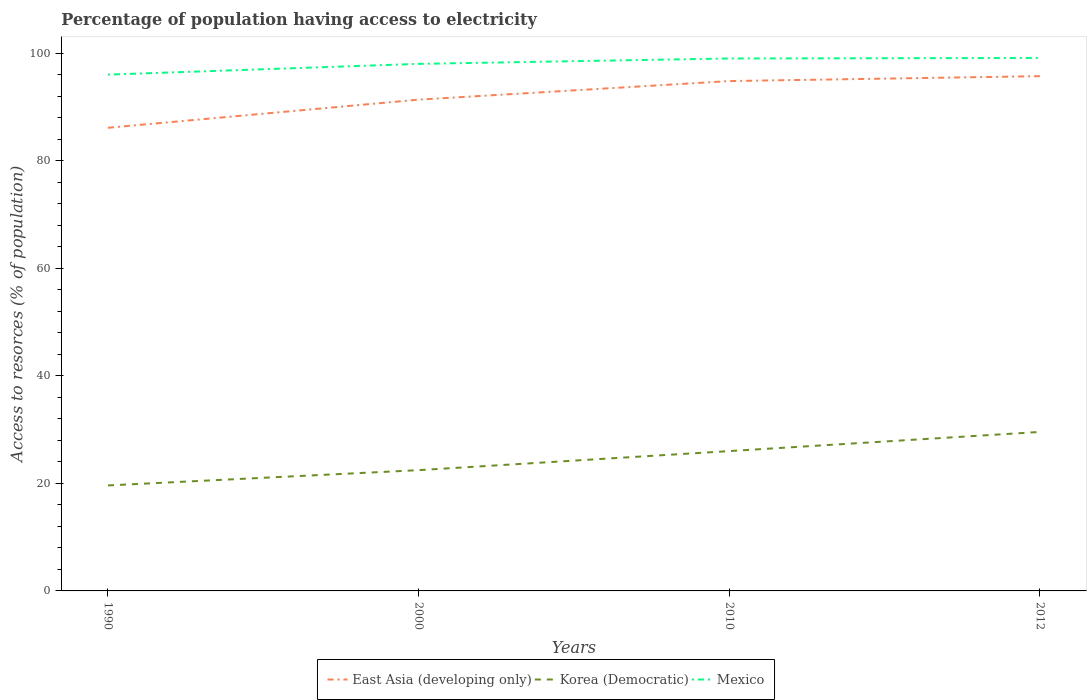How many different coloured lines are there?
Your response must be concise. 3. Across all years, what is the maximum percentage of population having access to electricity in Mexico?
Your response must be concise. 96. What is the total percentage of population having access to electricity in Mexico in the graph?
Ensure brevity in your answer.  -1.1. What is the difference between the highest and the second highest percentage of population having access to electricity in East Asia (developing only)?
Offer a terse response. 9.59. What is the difference between two consecutive major ticks on the Y-axis?
Give a very brief answer. 20. Does the graph contain any zero values?
Ensure brevity in your answer.  No. Does the graph contain grids?
Offer a terse response. No. Where does the legend appear in the graph?
Give a very brief answer. Bottom center. How are the legend labels stacked?
Make the answer very short. Horizontal. What is the title of the graph?
Your answer should be very brief. Percentage of population having access to electricity. Does "Thailand" appear as one of the legend labels in the graph?
Your answer should be compact. No. What is the label or title of the X-axis?
Provide a succinct answer. Years. What is the label or title of the Y-axis?
Offer a terse response. Access to resorces (% of population). What is the Access to resorces (% of population) in East Asia (developing only) in 1990?
Ensure brevity in your answer.  86.12. What is the Access to resorces (% of population) in Korea (Democratic) in 1990?
Your response must be concise. 19.62. What is the Access to resorces (% of population) of Mexico in 1990?
Your response must be concise. 96. What is the Access to resorces (% of population) in East Asia (developing only) in 2000?
Keep it short and to the point. 91.35. What is the Access to resorces (% of population) of Korea (Democratic) in 2000?
Offer a terse response. 22.46. What is the Access to resorces (% of population) of East Asia (developing only) in 2010?
Your response must be concise. 94.8. What is the Access to resorces (% of population) in Korea (Democratic) in 2010?
Your answer should be compact. 26. What is the Access to resorces (% of population) in Mexico in 2010?
Offer a very short reply. 99. What is the Access to resorces (% of population) in East Asia (developing only) in 2012?
Your response must be concise. 95.71. What is the Access to resorces (% of population) of Korea (Democratic) in 2012?
Provide a short and direct response. 29.56. What is the Access to resorces (% of population) of Mexico in 2012?
Your response must be concise. 99.1. Across all years, what is the maximum Access to resorces (% of population) in East Asia (developing only)?
Provide a succinct answer. 95.71. Across all years, what is the maximum Access to resorces (% of population) of Korea (Democratic)?
Your response must be concise. 29.56. Across all years, what is the maximum Access to resorces (% of population) in Mexico?
Offer a very short reply. 99.1. Across all years, what is the minimum Access to resorces (% of population) in East Asia (developing only)?
Ensure brevity in your answer.  86.12. Across all years, what is the minimum Access to resorces (% of population) in Korea (Democratic)?
Make the answer very short. 19.62. Across all years, what is the minimum Access to resorces (% of population) in Mexico?
Your answer should be compact. 96. What is the total Access to resorces (% of population) in East Asia (developing only) in the graph?
Provide a succinct answer. 367.98. What is the total Access to resorces (% of population) in Korea (Democratic) in the graph?
Offer a very short reply. 97.63. What is the total Access to resorces (% of population) in Mexico in the graph?
Make the answer very short. 392.1. What is the difference between the Access to resorces (% of population) of East Asia (developing only) in 1990 and that in 2000?
Provide a short and direct response. -5.23. What is the difference between the Access to resorces (% of population) of Korea (Democratic) in 1990 and that in 2000?
Keep it short and to the point. -2.84. What is the difference between the Access to resorces (% of population) in Mexico in 1990 and that in 2000?
Offer a terse response. -2. What is the difference between the Access to resorces (% of population) in East Asia (developing only) in 1990 and that in 2010?
Provide a short and direct response. -8.68. What is the difference between the Access to resorces (% of population) in Korea (Democratic) in 1990 and that in 2010?
Provide a succinct answer. -6.38. What is the difference between the Access to resorces (% of population) of Mexico in 1990 and that in 2010?
Provide a succinct answer. -3. What is the difference between the Access to resorces (% of population) in East Asia (developing only) in 1990 and that in 2012?
Offer a terse response. -9.59. What is the difference between the Access to resorces (% of population) of Korea (Democratic) in 1990 and that in 2012?
Your response must be concise. -9.95. What is the difference between the Access to resorces (% of population) of East Asia (developing only) in 2000 and that in 2010?
Offer a terse response. -3.45. What is the difference between the Access to resorces (% of population) in Korea (Democratic) in 2000 and that in 2010?
Your answer should be compact. -3.54. What is the difference between the Access to resorces (% of population) of Mexico in 2000 and that in 2010?
Provide a succinct answer. -1. What is the difference between the Access to resorces (% of population) of East Asia (developing only) in 2000 and that in 2012?
Make the answer very short. -4.36. What is the difference between the Access to resorces (% of population) of Korea (Democratic) in 2000 and that in 2012?
Offer a terse response. -7.11. What is the difference between the Access to resorces (% of population) in Mexico in 2000 and that in 2012?
Offer a terse response. -1.1. What is the difference between the Access to resorces (% of population) in East Asia (developing only) in 2010 and that in 2012?
Your answer should be very brief. -0.91. What is the difference between the Access to resorces (% of population) of Korea (Democratic) in 2010 and that in 2012?
Your response must be concise. -3.56. What is the difference between the Access to resorces (% of population) in Mexico in 2010 and that in 2012?
Your answer should be very brief. -0.1. What is the difference between the Access to resorces (% of population) in East Asia (developing only) in 1990 and the Access to resorces (% of population) in Korea (Democratic) in 2000?
Provide a succinct answer. 63.66. What is the difference between the Access to resorces (% of population) of East Asia (developing only) in 1990 and the Access to resorces (% of population) of Mexico in 2000?
Give a very brief answer. -11.88. What is the difference between the Access to resorces (% of population) in Korea (Democratic) in 1990 and the Access to resorces (% of population) in Mexico in 2000?
Provide a succinct answer. -78.38. What is the difference between the Access to resorces (% of population) of East Asia (developing only) in 1990 and the Access to resorces (% of population) of Korea (Democratic) in 2010?
Provide a succinct answer. 60.12. What is the difference between the Access to resorces (% of population) in East Asia (developing only) in 1990 and the Access to resorces (% of population) in Mexico in 2010?
Keep it short and to the point. -12.88. What is the difference between the Access to resorces (% of population) of Korea (Democratic) in 1990 and the Access to resorces (% of population) of Mexico in 2010?
Your answer should be compact. -79.38. What is the difference between the Access to resorces (% of population) of East Asia (developing only) in 1990 and the Access to resorces (% of population) of Korea (Democratic) in 2012?
Make the answer very short. 56.56. What is the difference between the Access to resorces (% of population) of East Asia (developing only) in 1990 and the Access to resorces (% of population) of Mexico in 2012?
Make the answer very short. -12.98. What is the difference between the Access to resorces (% of population) in Korea (Democratic) in 1990 and the Access to resorces (% of population) in Mexico in 2012?
Your response must be concise. -79.48. What is the difference between the Access to resorces (% of population) in East Asia (developing only) in 2000 and the Access to resorces (% of population) in Korea (Democratic) in 2010?
Provide a short and direct response. 65.35. What is the difference between the Access to resorces (% of population) in East Asia (developing only) in 2000 and the Access to resorces (% of population) in Mexico in 2010?
Provide a short and direct response. -7.65. What is the difference between the Access to resorces (% of population) in Korea (Democratic) in 2000 and the Access to resorces (% of population) in Mexico in 2010?
Your answer should be compact. -76.54. What is the difference between the Access to resorces (% of population) in East Asia (developing only) in 2000 and the Access to resorces (% of population) in Korea (Democratic) in 2012?
Offer a terse response. 61.79. What is the difference between the Access to resorces (% of population) in East Asia (developing only) in 2000 and the Access to resorces (% of population) in Mexico in 2012?
Ensure brevity in your answer.  -7.75. What is the difference between the Access to resorces (% of population) of Korea (Democratic) in 2000 and the Access to resorces (% of population) of Mexico in 2012?
Your answer should be very brief. -76.64. What is the difference between the Access to resorces (% of population) of East Asia (developing only) in 2010 and the Access to resorces (% of population) of Korea (Democratic) in 2012?
Offer a very short reply. 65.24. What is the difference between the Access to resorces (% of population) in Korea (Democratic) in 2010 and the Access to resorces (% of population) in Mexico in 2012?
Offer a very short reply. -73.1. What is the average Access to resorces (% of population) in East Asia (developing only) per year?
Keep it short and to the point. 92. What is the average Access to resorces (% of population) of Korea (Democratic) per year?
Provide a succinct answer. 24.41. What is the average Access to resorces (% of population) in Mexico per year?
Provide a short and direct response. 98.03. In the year 1990, what is the difference between the Access to resorces (% of population) of East Asia (developing only) and Access to resorces (% of population) of Korea (Democratic)?
Ensure brevity in your answer.  66.5. In the year 1990, what is the difference between the Access to resorces (% of population) in East Asia (developing only) and Access to resorces (% of population) in Mexico?
Provide a short and direct response. -9.88. In the year 1990, what is the difference between the Access to resorces (% of population) in Korea (Democratic) and Access to resorces (% of population) in Mexico?
Your answer should be compact. -76.38. In the year 2000, what is the difference between the Access to resorces (% of population) of East Asia (developing only) and Access to resorces (% of population) of Korea (Democratic)?
Give a very brief answer. 68.89. In the year 2000, what is the difference between the Access to resorces (% of population) of East Asia (developing only) and Access to resorces (% of population) of Mexico?
Keep it short and to the point. -6.65. In the year 2000, what is the difference between the Access to resorces (% of population) in Korea (Democratic) and Access to resorces (% of population) in Mexico?
Your response must be concise. -75.54. In the year 2010, what is the difference between the Access to resorces (% of population) of East Asia (developing only) and Access to resorces (% of population) of Korea (Democratic)?
Your response must be concise. 68.8. In the year 2010, what is the difference between the Access to resorces (% of population) of Korea (Democratic) and Access to resorces (% of population) of Mexico?
Keep it short and to the point. -73. In the year 2012, what is the difference between the Access to resorces (% of population) in East Asia (developing only) and Access to resorces (% of population) in Korea (Democratic)?
Make the answer very short. 66.15. In the year 2012, what is the difference between the Access to resorces (% of population) of East Asia (developing only) and Access to resorces (% of population) of Mexico?
Offer a very short reply. -3.39. In the year 2012, what is the difference between the Access to resorces (% of population) of Korea (Democratic) and Access to resorces (% of population) of Mexico?
Offer a very short reply. -69.54. What is the ratio of the Access to resorces (% of population) of East Asia (developing only) in 1990 to that in 2000?
Make the answer very short. 0.94. What is the ratio of the Access to resorces (% of population) of Korea (Democratic) in 1990 to that in 2000?
Your answer should be very brief. 0.87. What is the ratio of the Access to resorces (% of population) of Mexico in 1990 to that in 2000?
Offer a very short reply. 0.98. What is the ratio of the Access to resorces (% of population) in East Asia (developing only) in 1990 to that in 2010?
Give a very brief answer. 0.91. What is the ratio of the Access to resorces (% of population) in Korea (Democratic) in 1990 to that in 2010?
Keep it short and to the point. 0.75. What is the ratio of the Access to resorces (% of population) in Mexico in 1990 to that in 2010?
Offer a very short reply. 0.97. What is the ratio of the Access to resorces (% of population) of East Asia (developing only) in 1990 to that in 2012?
Ensure brevity in your answer.  0.9. What is the ratio of the Access to resorces (% of population) in Korea (Democratic) in 1990 to that in 2012?
Ensure brevity in your answer.  0.66. What is the ratio of the Access to resorces (% of population) in Mexico in 1990 to that in 2012?
Keep it short and to the point. 0.97. What is the ratio of the Access to resorces (% of population) in East Asia (developing only) in 2000 to that in 2010?
Offer a very short reply. 0.96. What is the ratio of the Access to resorces (% of population) of Korea (Democratic) in 2000 to that in 2010?
Provide a short and direct response. 0.86. What is the ratio of the Access to resorces (% of population) of Mexico in 2000 to that in 2010?
Keep it short and to the point. 0.99. What is the ratio of the Access to resorces (% of population) of East Asia (developing only) in 2000 to that in 2012?
Give a very brief answer. 0.95. What is the ratio of the Access to resorces (% of population) of Korea (Democratic) in 2000 to that in 2012?
Offer a terse response. 0.76. What is the ratio of the Access to resorces (% of population) of Mexico in 2000 to that in 2012?
Your response must be concise. 0.99. What is the ratio of the Access to resorces (% of population) of Korea (Democratic) in 2010 to that in 2012?
Your response must be concise. 0.88. What is the ratio of the Access to resorces (% of population) of Mexico in 2010 to that in 2012?
Offer a very short reply. 1. What is the difference between the highest and the second highest Access to resorces (% of population) in East Asia (developing only)?
Keep it short and to the point. 0.91. What is the difference between the highest and the second highest Access to resorces (% of population) in Korea (Democratic)?
Make the answer very short. 3.56. What is the difference between the highest and the lowest Access to resorces (% of population) in East Asia (developing only)?
Give a very brief answer. 9.59. What is the difference between the highest and the lowest Access to resorces (% of population) of Korea (Democratic)?
Give a very brief answer. 9.95. 